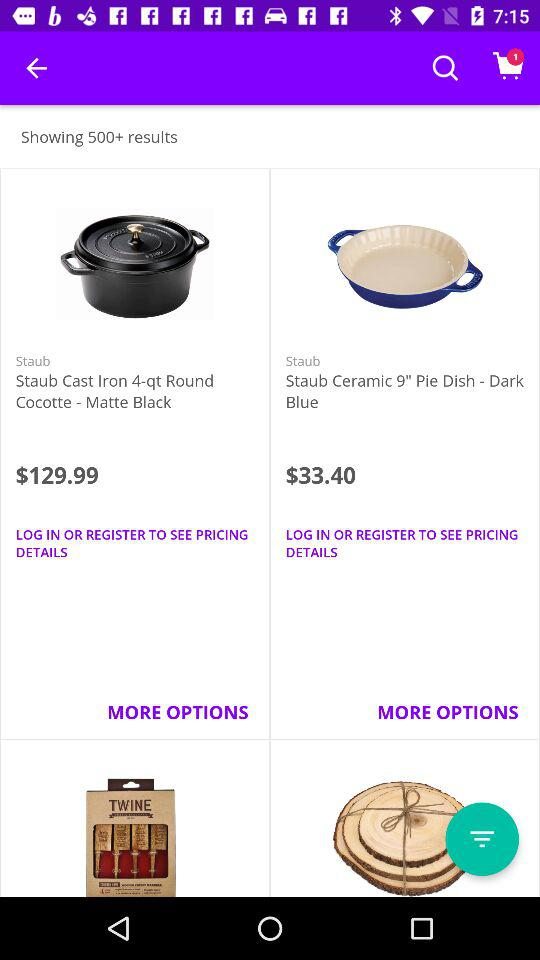How many items are priced under $130?
Answer the question using a single word or phrase. 2 